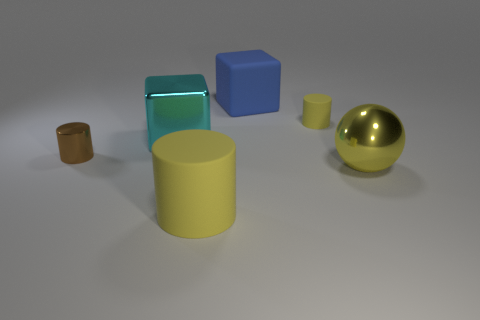Subtract all cyan balls. Subtract all gray blocks. How many balls are left? 1 Add 2 small metallic balls. How many objects exist? 8 Subtract all cubes. How many objects are left? 4 Add 5 large purple blocks. How many large purple blocks exist? 5 Subtract 0 gray cylinders. How many objects are left? 6 Subtract all metallic cubes. Subtract all big cyan cubes. How many objects are left? 4 Add 1 brown shiny cylinders. How many brown shiny cylinders are left? 2 